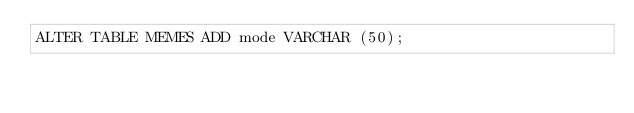<code> <loc_0><loc_0><loc_500><loc_500><_SQL_>ALTER TABLE MEMES ADD mode VARCHAR (50);</code> 